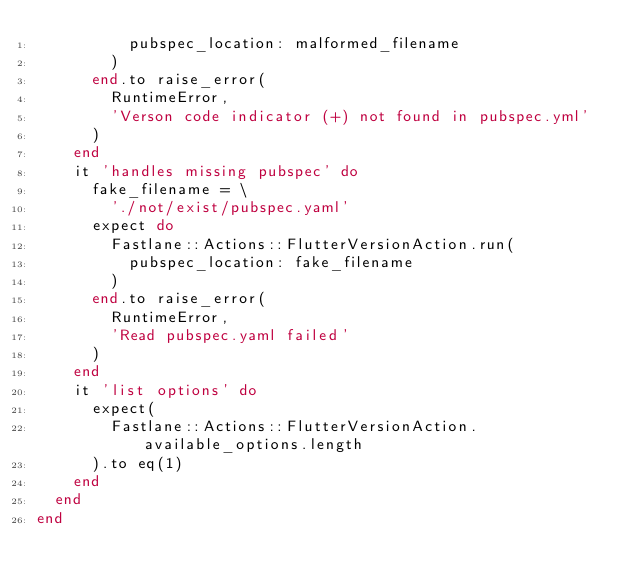Convert code to text. <code><loc_0><loc_0><loc_500><loc_500><_Ruby_>          pubspec_location: malformed_filename
        )
      end.to raise_error(
        RuntimeError,
        'Verson code indicator (+) not found in pubspec.yml'
      )
    end
    it 'handles missing pubspec' do
      fake_filename = \
        './not/exist/pubspec.yaml'
      expect do
        Fastlane::Actions::FlutterVersionAction.run(
          pubspec_location: fake_filename
        )
      end.to raise_error(
        RuntimeError,
        'Read pubspec.yaml failed'
      )
    end
    it 'list options' do
      expect(
        Fastlane::Actions::FlutterVersionAction.available_options.length
      ).to eq(1)
    end
  end
end
</code> 